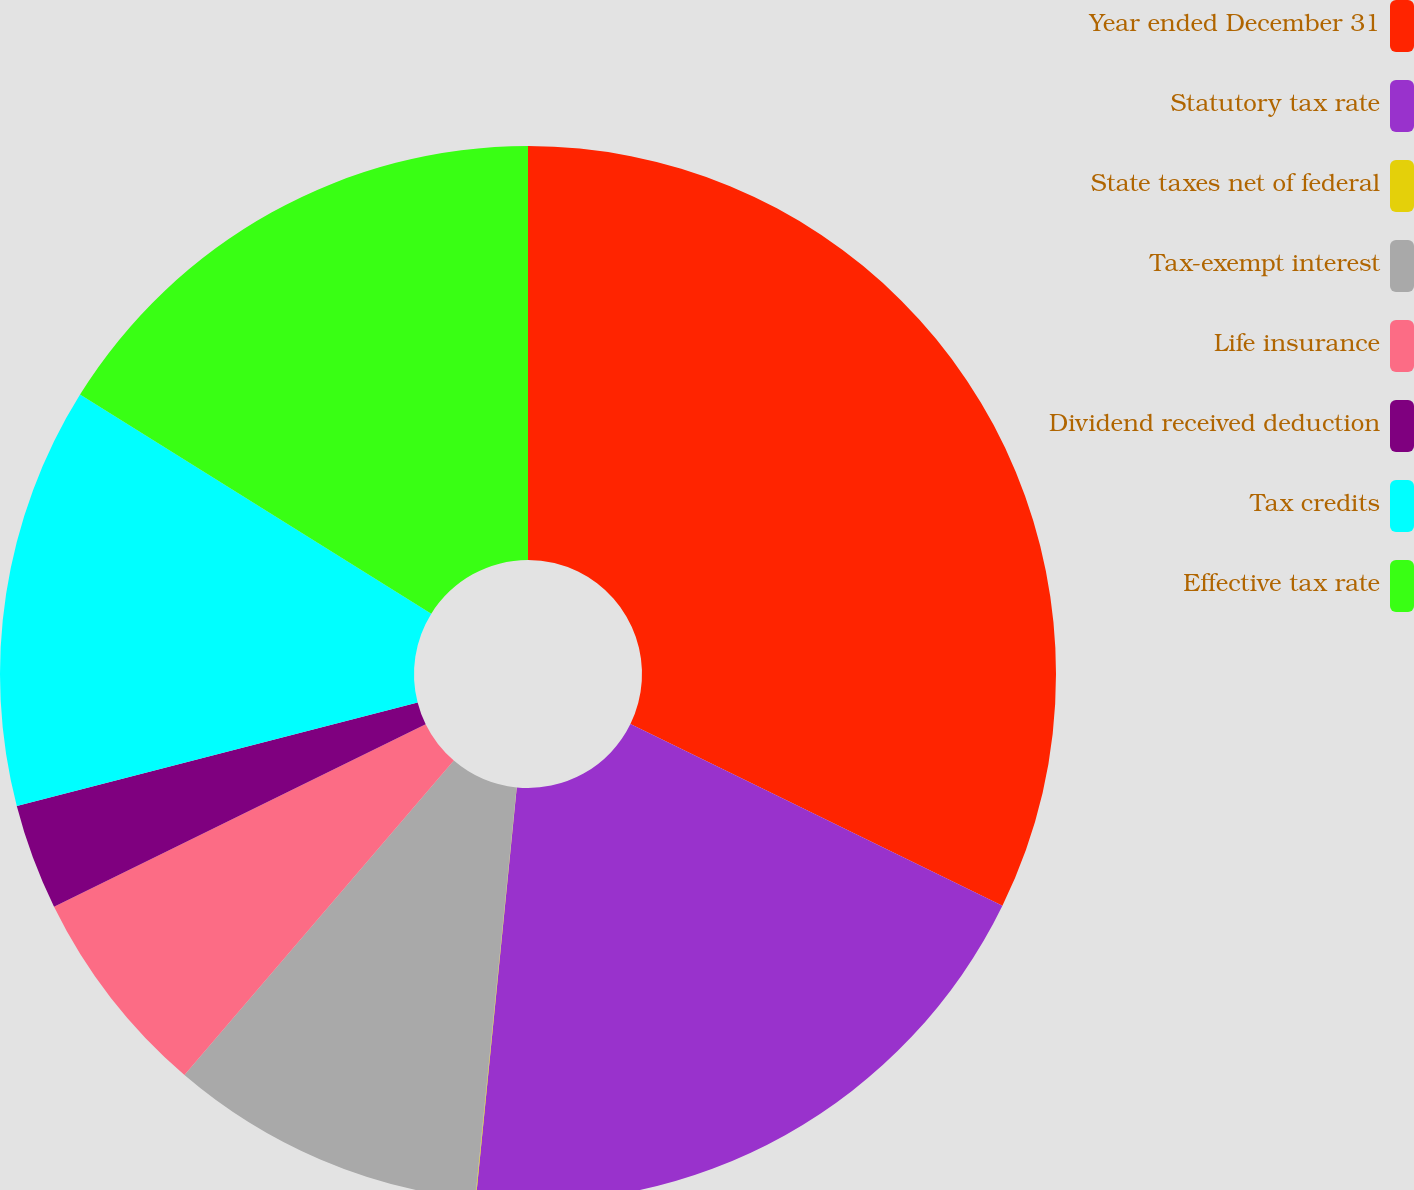Convert chart to OTSL. <chart><loc_0><loc_0><loc_500><loc_500><pie_chart><fcel>Year ended December 31<fcel>Statutory tax rate<fcel>State taxes net of federal<fcel>Tax-exempt interest<fcel>Life insurance<fcel>Dividend received deduction<fcel>Tax credits<fcel>Effective tax rate<nl><fcel>32.23%<fcel>19.34%<fcel>0.02%<fcel>9.68%<fcel>6.46%<fcel>3.24%<fcel>12.9%<fcel>16.12%<nl></chart> 